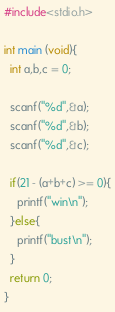<code> <loc_0><loc_0><loc_500><loc_500><_C_>#include<stdio.h>

int main (void){
  int a,b,c = 0;

  scanf("%d",&a);
  scanf("%d",&b);
  scanf("%d",&c);

  if(21 - (a+b+c) >= 0){
    printf("win\n");
  }else{
    printf("bust\n");
  }
  return 0;
}
</code> 